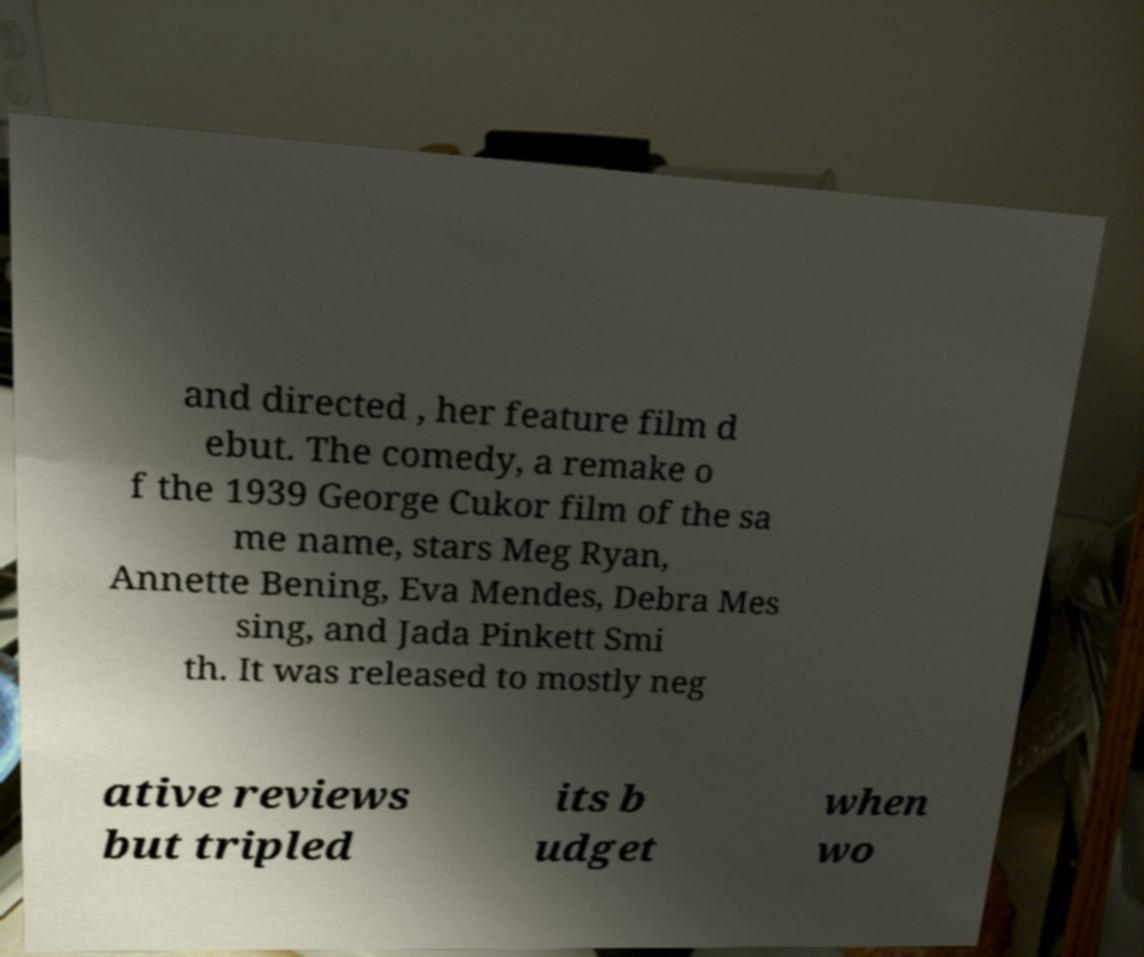What messages or text are displayed in this image? I need them in a readable, typed format. and directed , her feature film d ebut. The comedy, a remake o f the 1939 George Cukor film of the sa me name, stars Meg Ryan, Annette Bening, Eva Mendes, Debra Mes sing, and Jada Pinkett Smi th. It was released to mostly neg ative reviews but tripled its b udget when wo 